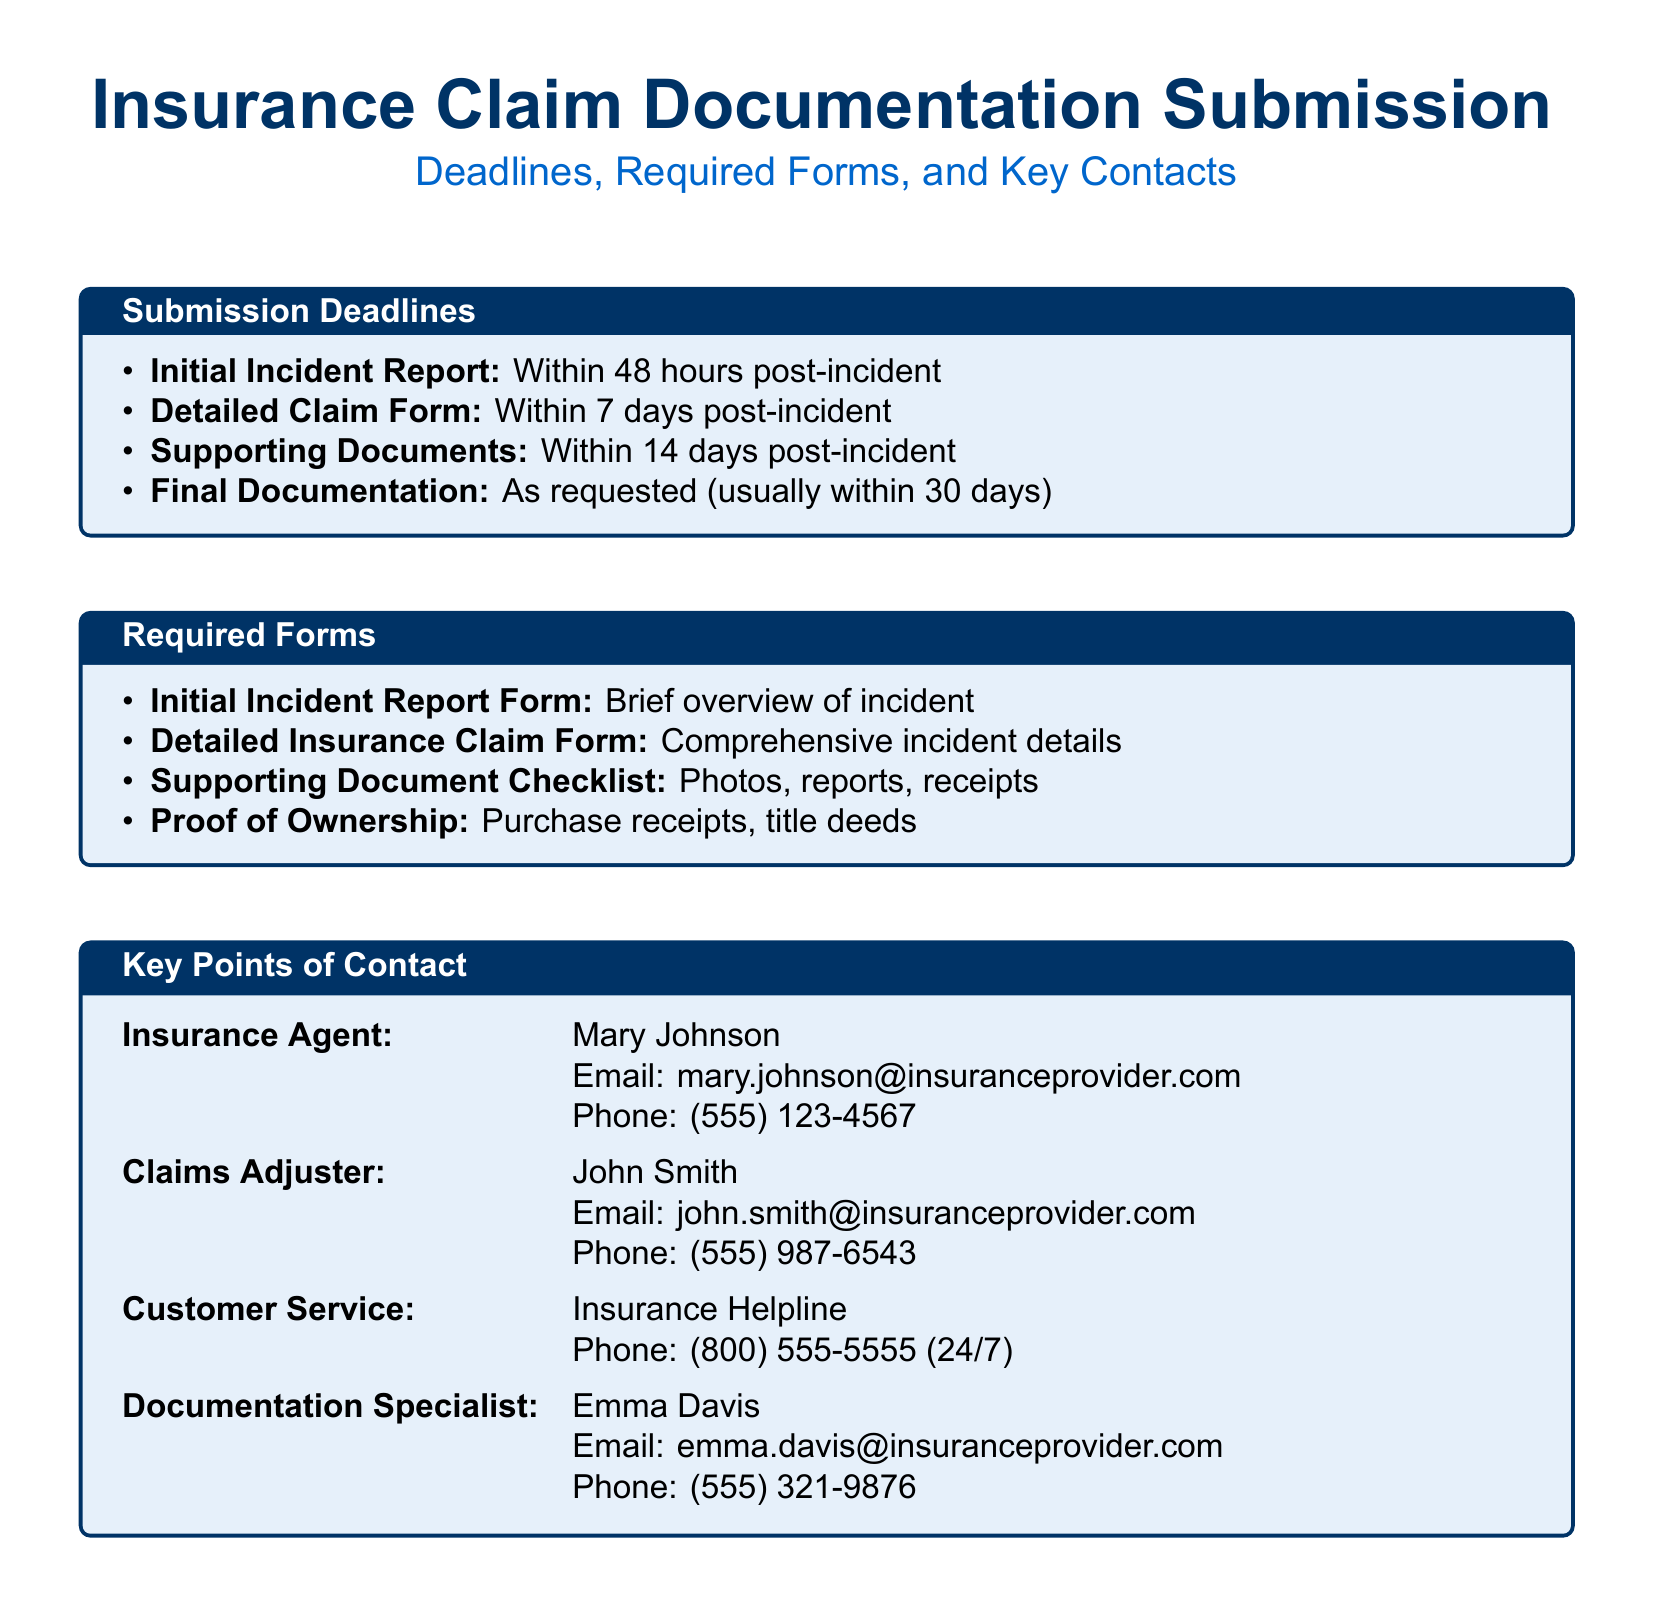what is the deadline for the Initial Incident Report? The deadline for the Initial Incident Report is stated in the Submission Deadlines section of the document, which specifies that it should be submitted within 48 hours post-incident.
Answer: 48 hours when should the Supporting Documents be submitted? The document outlines that Supporting Documents need to be submitted within 14 days post-incident, which can be found in the Submission Deadlines section.
Answer: 14 days who is the Claims Adjuster? The Claims Adjuster is mentioned in the Key Points of Contact section, specifying the name and contact details of the individual responsible for handling claims.
Answer: John Smith what form is required for a brief overview of the incident? According to the Required Forms section, the document specifies the Initial Incident Report Form is required for a brief overview of the incident.
Answer: Initial Incident Report Form what is the purpose of the Proof of Ownership? The document mentions the Proof of Ownership in the Required Forms section, indicating that it serves to verify ownership of the claimed items through certain documents.
Answer: Verify ownership how long after the incident should the Detailed Claim Form be submitted? The timeframe for submitting the Detailed Claim Form is provided in the Submission Deadlines section, indicating it must be done within 7 days after the incident.
Answer: 7 days what is the email address for Customer Service inquiries? The Key Points of Contact section includes the information for the Customer Service helpline but does not provide a specific email address, as it only lists a phone number.
Answer: Not provided which documentation needs to be submitted last? The document indicates that the Final Documentation is usually requested and is to be submitted within 30 days, referenced in the Submission Deadlines section.
Answer: Final Documentation how many key contacts are listed in the document? The number of key contacts is determined by counting each of the distinct roles listed in the Key Points of Contact section of the document.
Answer: Four 